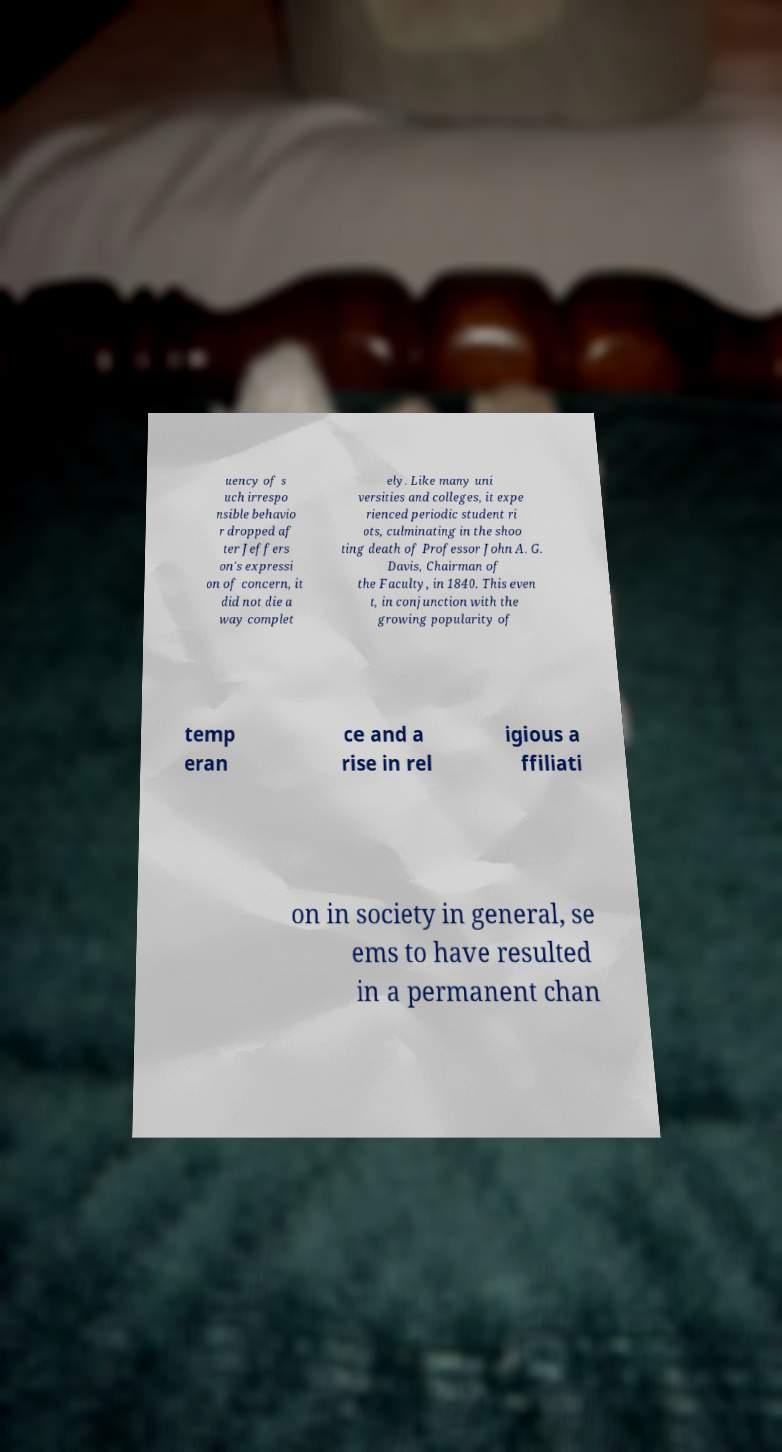Could you extract and type out the text from this image? uency of s uch irrespo nsible behavio r dropped af ter Jeffers on's expressi on of concern, it did not die a way complet ely. Like many uni versities and colleges, it expe rienced periodic student ri ots, culminating in the shoo ting death of Professor John A. G. Davis, Chairman of the Faculty, in 1840. This even t, in conjunction with the growing popularity of temp eran ce and a rise in rel igious a ffiliati on in society in general, se ems to have resulted in a permanent chan 